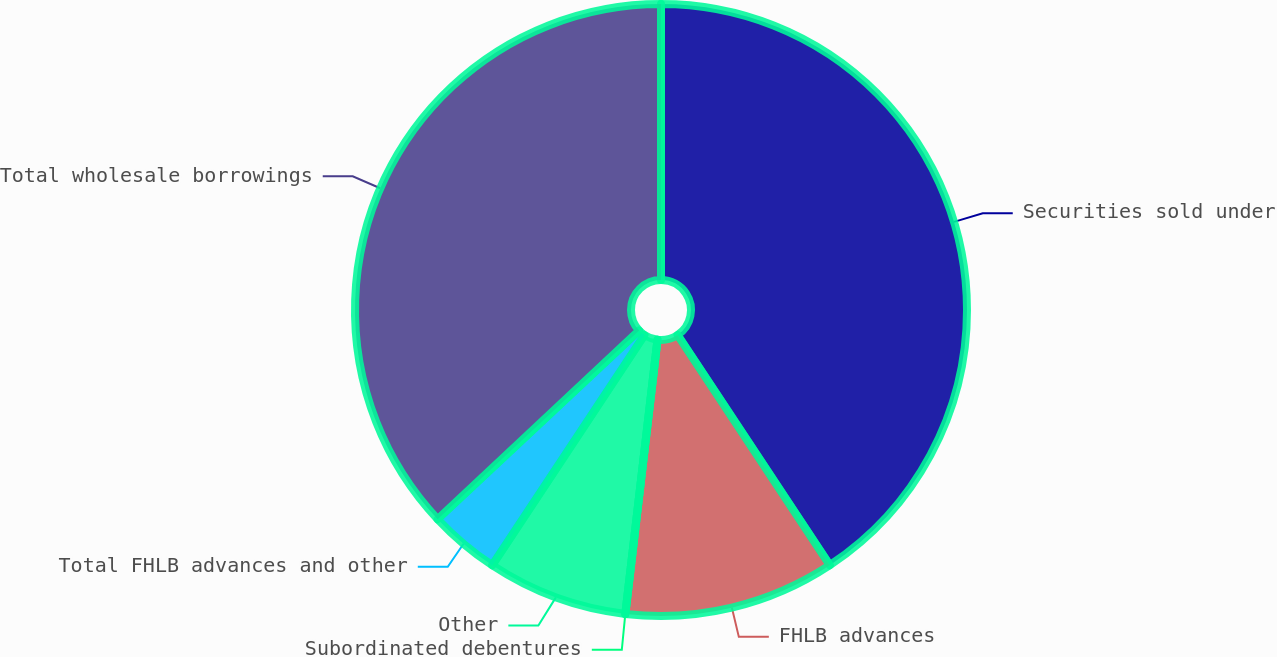Convert chart. <chart><loc_0><loc_0><loc_500><loc_500><pie_chart><fcel>Securities sold under<fcel>FHLB advances<fcel>Subordinated debentures<fcel>Other<fcel>Total FHLB advances and other<fcel>Total wholesale borrowings<nl><fcel>40.69%<fcel>11.16%<fcel>0.0%<fcel>7.44%<fcel>3.72%<fcel>36.97%<nl></chart> 